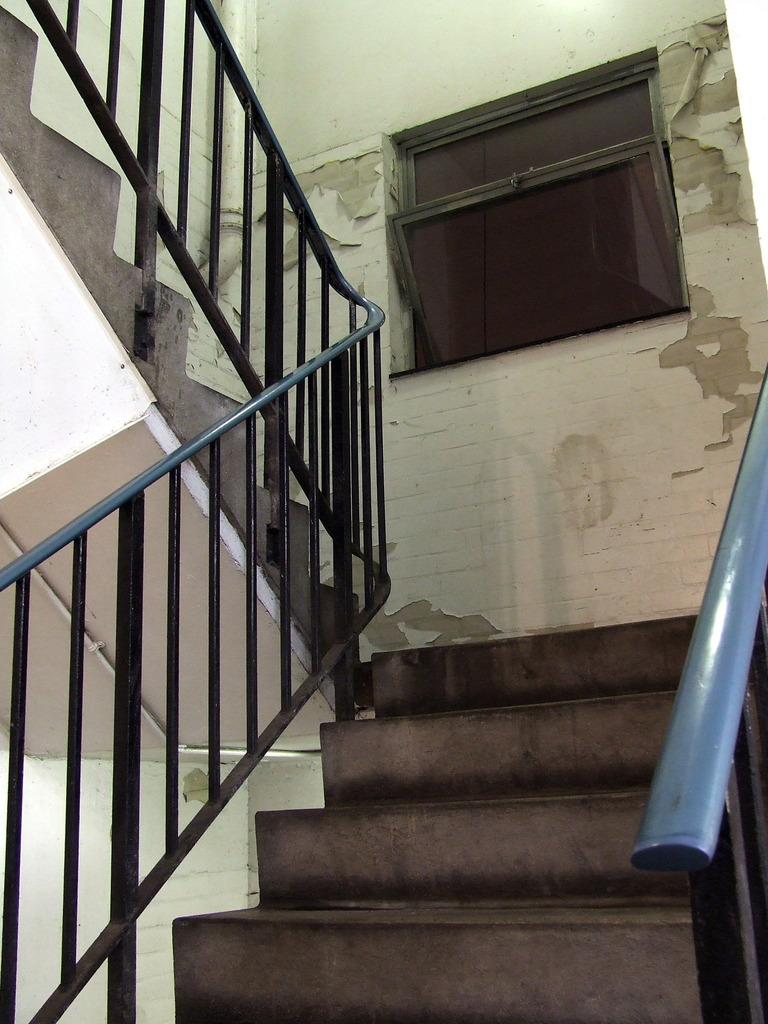What type of structure is present in the image? There is a staircase in the image. What can be seen in the background of the image? There is a wall in the background of the image. Is there any opening in the wall visible in the image? Yes, there is a window in the wall in the background of the image. What type of vessel is being used to clear the throat in the image? There is no vessel or throat-clearing activity present in the image. 